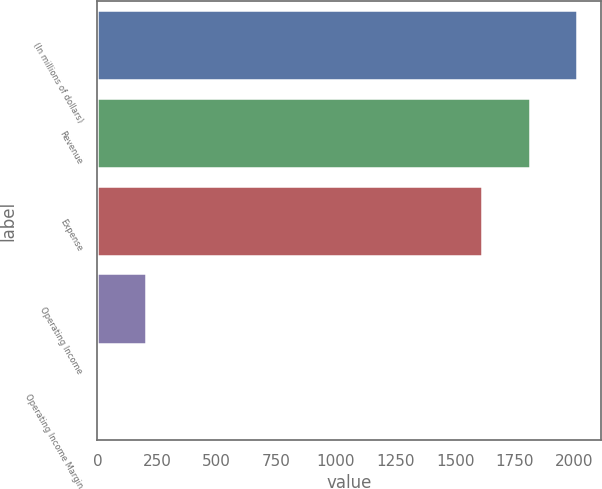<chart> <loc_0><loc_0><loc_500><loc_500><bar_chart><fcel>(In millions of dollars)<fcel>Revenue<fcel>Expense<fcel>Operating Income<fcel>Operating Income Margin<nl><fcel>2011.66<fcel>1811.83<fcel>1612<fcel>205.53<fcel>5.7<nl></chart> 